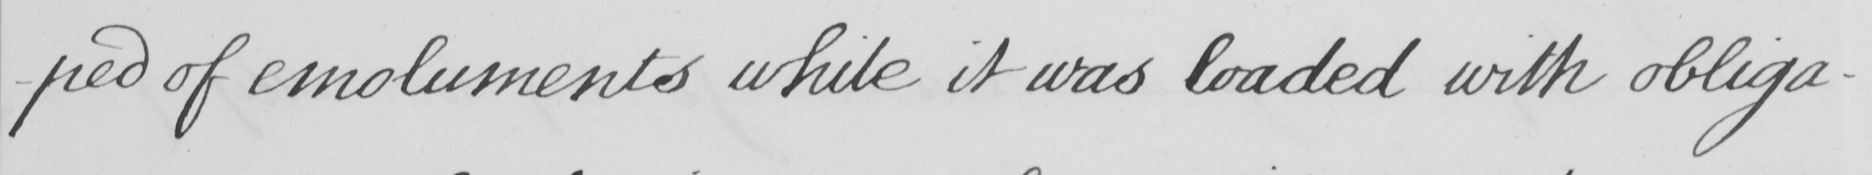What text is written in this handwritten line? -ped of emoluments while it was loaded with obliga- 